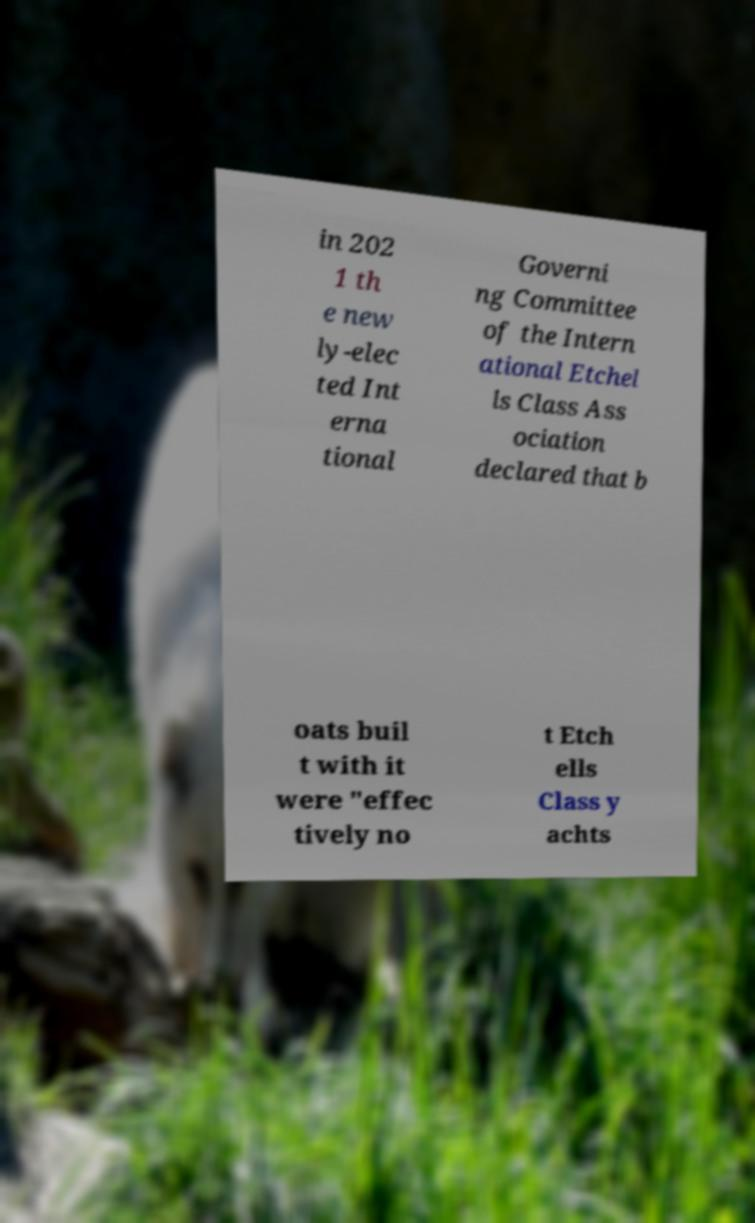There's text embedded in this image that I need extracted. Can you transcribe it verbatim? in 202 1 th e new ly-elec ted Int erna tional Governi ng Committee of the Intern ational Etchel ls Class Ass ociation declared that b oats buil t with it were "effec tively no t Etch ells Class y achts 